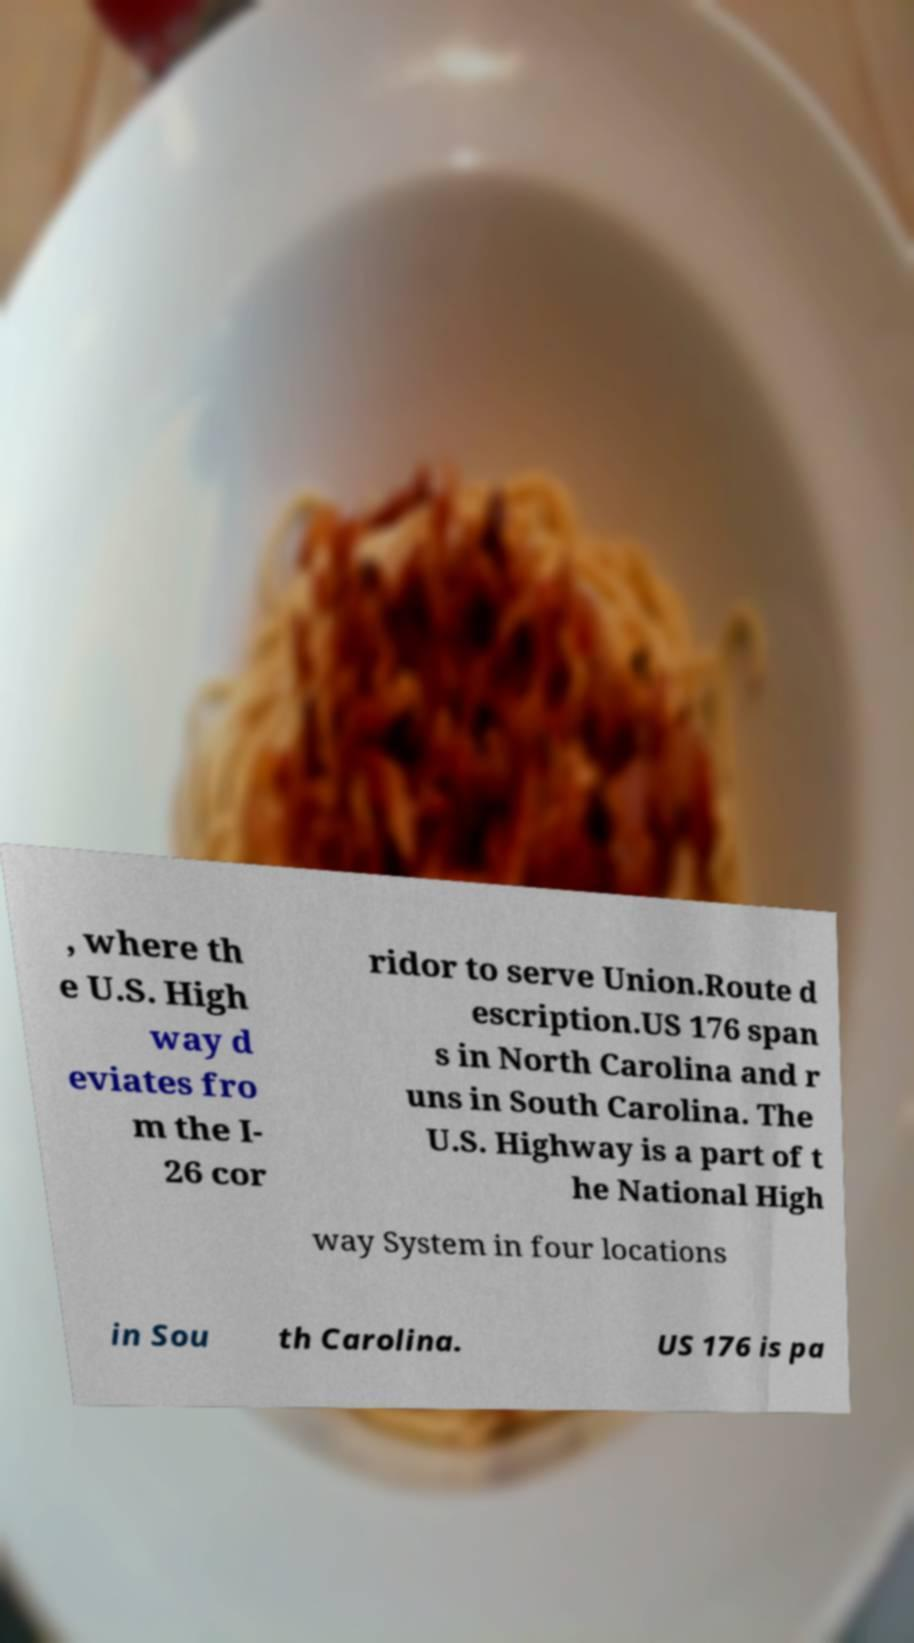Can you read and provide the text displayed in the image?This photo seems to have some interesting text. Can you extract and type it out for me? , where th e U.S. High way d eviates fro m the I- 26 cor ridor to serve Union.Route d escription.US 176 span s in North Carolina and r uns in South Carolina. The U.S. Highway is a part of t he National High way System in four locations in Sou th Carolina. US 176 is pa 